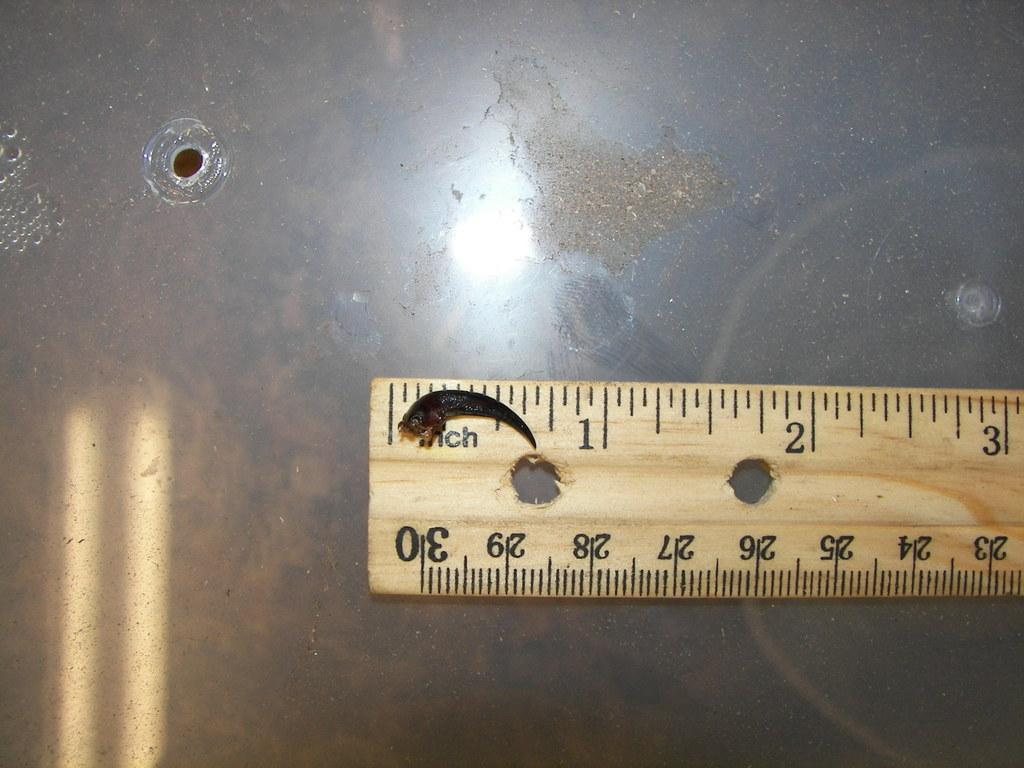Provide a one-sentence caption for the provided image. A small creature is being measured on a ruler stick. 